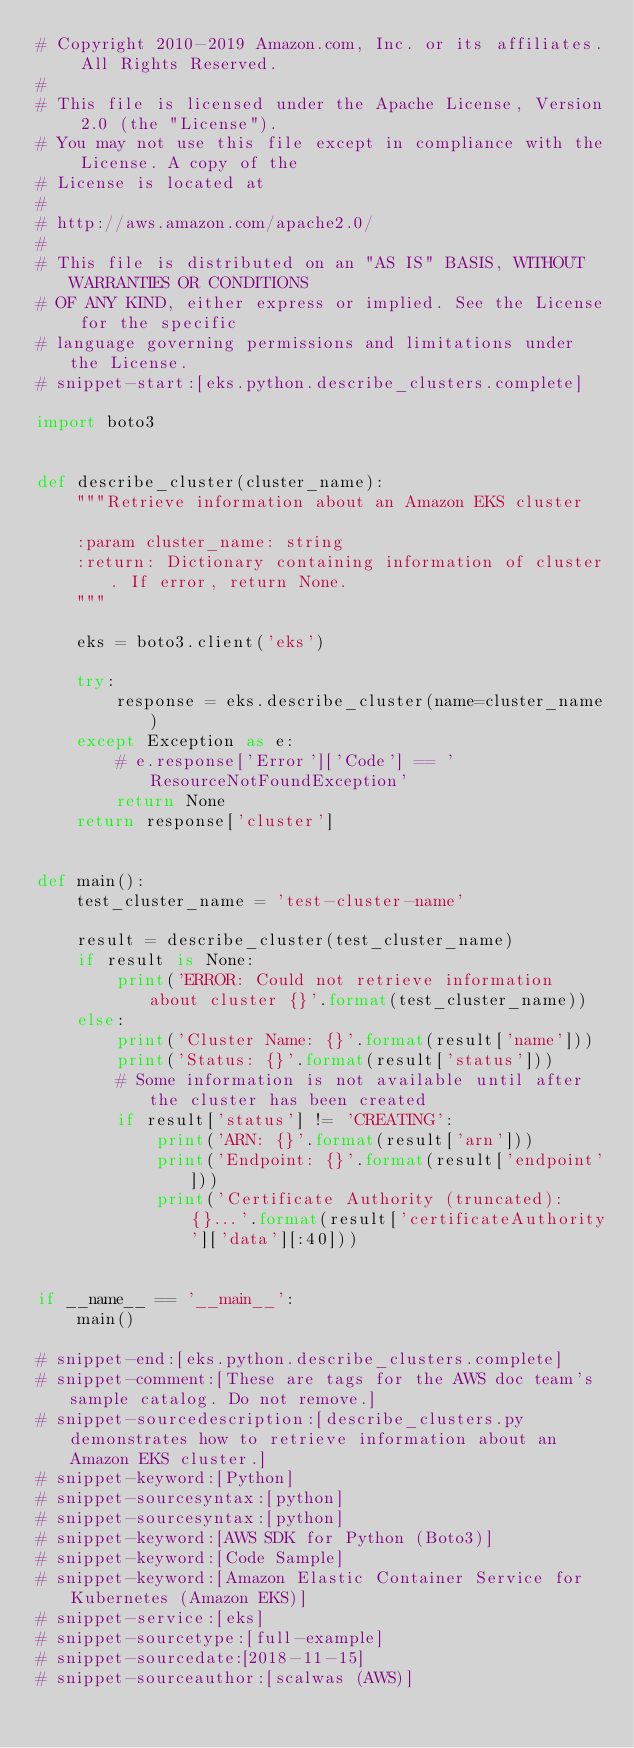Convert code to text. <code><loc_0><loc_0><loc_500><loc_500><_Python_># Copyright 2010-2019 Amazon.com, Inc. or its affiliates. All Rights Reserved.
#
# This file is licensed under the Apache License, Version 2.0 (the "License").
# You may not use this file except in compliance with the License. A copy of the
# License is located at
#
# http://aws.amazon.com/apache2.0/
#
# This file is distributed on an "AS IS" BASIS, WITHOUT WARRANTIES OR CONDITIONS
# OF ANY KIND, either express or implied. See the License for the specific
# language governing permissions and limitations under the License. 
# snippet-start:[eks.python.describe_clusters.complete]

import boto3


def describe_cluster(cluster_name):
    """Retrieve information about an Amazon EKS cluster

    :param cluster_name: string
    :return: Dictionary containing information of cluster. If error, return None.
    """

    eks = boto3.client('eks')

    try:
        response = eks.describe_cluster(name=cluster_name)
    except Exception as e:
        # e.response['Error']['Code'] == 'ResourceNotFoundException'
        return None
    return response['cluster']


def main():
    test_cluster_name = 'test-cluster-name'

    result = describe_cluster(test_cluster_name)
    if result is None:
        print('ERROR: Could not retrieve information about cluster {}'.format(test_cluster_name))
    else:
        print('Cluster Name: {}'.format(result['name']))
        print('Status: {}'.format(result['status']))
        # Some information is not available until after the cluster has been created
        if result['status'] != 'CREATING':
            print('ARN: {}'.format(result['arn']))
            print('Endpoint: {}'.format(result['endpoint']))
            print('Certificate Authority (truncated): {}...'.format(result['certificateAuthority']['data'][:40]))


if __name__ == '__main__':
    main()

# snippet-end:[eks.python.describe_clusters.complete]
# snippet-comment:[These are tags for the AWS doc team's sample catalog. Do not remove.]
# snippet-sourcedescription:[describe_clusters.py demonstrates how to retrieve information about an Amazon EKS cluster.]
# snippet-keyword:[Python]
# snippet-sourcesyntax:[python]
# snippet-sourcesyntax:[python]
# snippet-keyword:[AWS SDK for Python (Boto3)]
# snippet-keyword:[Code Sample]
# snippet-keyword:[Amazon Elastic Container Service for Kubernetes (Amazon EKS)]
# snippet-service:[eks]
# snippet-sourcetype:[full-example]
# snippet-sourcedate:[2018-11-15]
# snippet-sourceauthor:[scalwas (AWS)]

</code> 